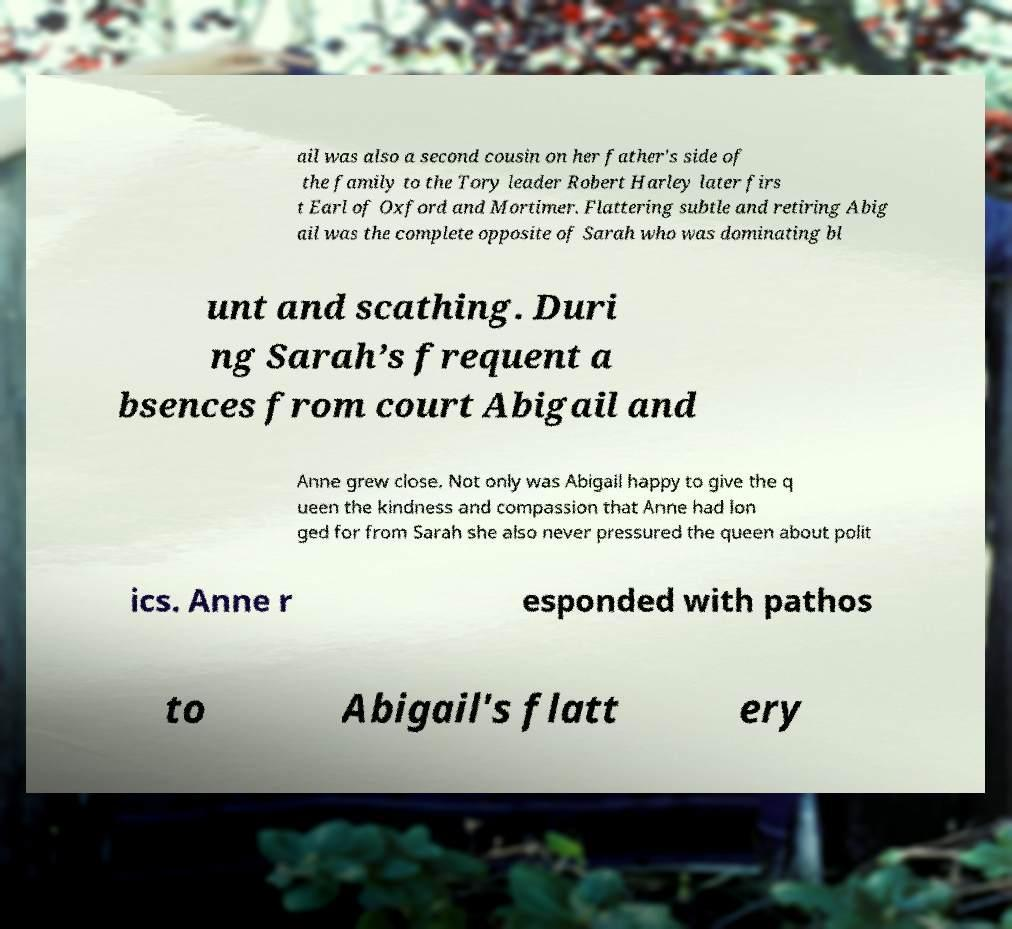Please read and relay the text visible in this image. What does it say? ail was also a second cousin on her father's side of the family to the Tory leader Robert Harley later firs t Earl of Oxford and Mortimer. Flattering subtle and retiring Abig ail was the complete opposite of Sarah who was dominating bl unt and scathing. Duri ng Sarah’s frequent a bsences from court Abigail and Anne grew close. Not only was Abigail happy to give the q ueen the kindness and compassion that Anne had lon ged for from Sarah she also never pressured the queen about polit ics. Anne r esponded with pathos to Abigail's flatt ery 